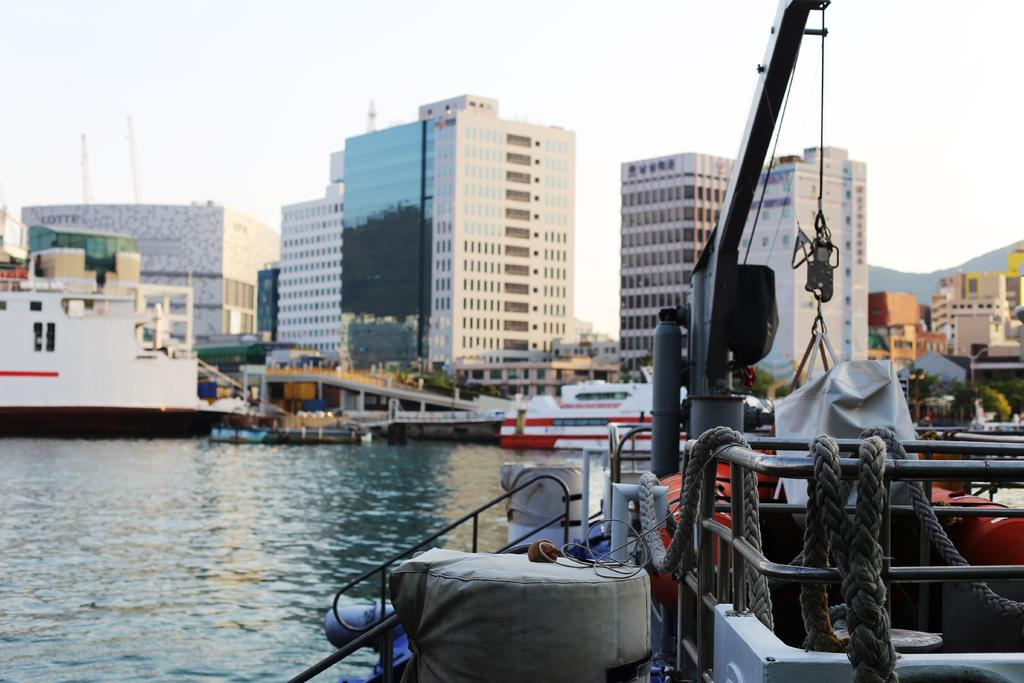What can be seen traveling on the river in the image? There are ships on the river in the image. What structures are located at the center of the image? There are buildings at the center of the image. What part of the natural environment is visible in the image? The sky is visible in the background of the image. What type of impulse can be seen affecting the movement of the ships in the image? There is no indication of any impulse affecting the movement of the ships in the image. What is the end result of the river in the image? The image does not show the end result of the river; it only shows the ships traveling on it. 